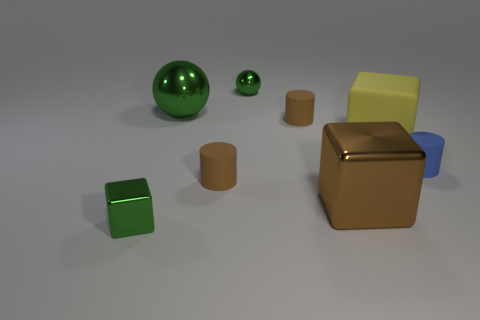Subtract all brown balls. How many brown cylinders are left? 2 Add 2 small brown rubber objects. How many objects exist? 10 Subtract all metallic blocks. How many blocks are left? 1 Subtract all spheres. How many objects are left? 6 Add 2 blue rubber cylinders. How many blue rubber cylinders are left? 3 Add 8 shiny spheres. How many shiny spheres exist? 10 Subtract 1 brown blocks. How many objects are left? 7 Subtract all cyan blocks. Subtract all brown cylinders. How many blocks are left? 3 Subtract all tiny yellow metallic objects. Subtract all large yellow blocks. How many objects are left? 7 